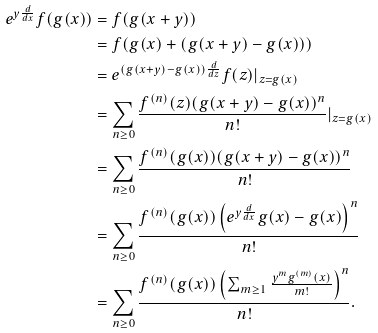Convert formula to latex. <formula><loc_0><loc_0><loc_500><loc_500>e ^ { y \frac { d } { d x } } f ( g ( x ) ) & = f ( g ( x + y ) ) \\ & = f ( g ( x ) + ( g ( x + y ) - g ( x ) ) ) \\ & = e ^ { ( g ( x + y ) - g ( x ) ) \frac { d } { d z } } f ( z ) | _ { z = g ( x ) } \\ & = \sum _ { n \geq 0 } \frac { f ^ { ( n ) } ( z ) ( g ( x + y ) - g ( x ) ) ^ { n } } { n ! } | _ { z = g ( x ) } \\ & = \sum _ { n \geq 0 } \frac { f ^ { ( n ) } ( g ( x ) ) ( g ( x + y ) - g ( x ) ) ^ { n } } { n ! } \\ & = \sum _ { n \geq 0 } \frac { f ^ { ( n ) } ( g ( x ) ) \left ( e ^ { y \frac { d } { d x } } g ( x ) - g ( x ) \right ) ^ { n } } { n ! } \\ & = \sum _ { n \geq 0 } \frac { f ^ { ( n ) } ( g ( x ) ) \left ( \sum _ { m \geq 1 } \frac { y ^ { m } g ^ { ( m ) } ( x ) } { m ! } \right ) ^ { n } } { n ! } .</formula> 